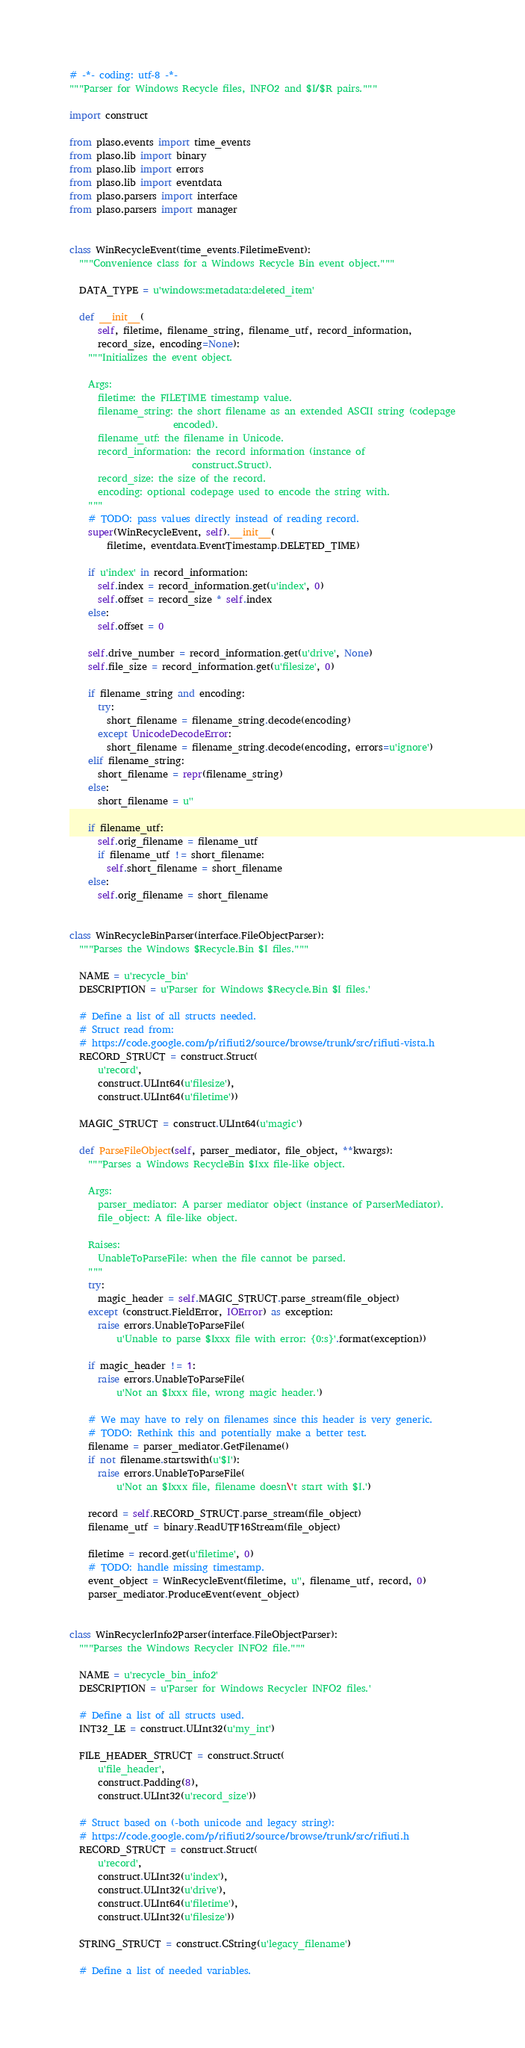<code> <loc_0><loc_0><loc_500><loc_500><_Python_># -*- coding: utf-8 -*-
"""Parser for Windows Recycle files, INFO2 and $I/$R pairs."""

import construct

from plaso.events import time_events
from plaso.lib import binary
from plaso.lib import errors
from plaso.lib import eventdata
from plaso.parsers import interface
from plaso.parsers import manager


class WinRecycleEvent(time_events.FiletimeEvent):
  """Convenience class for a Windows Recycle Bin event object."""

  DATA_TYPE = u'windows:metadata:deleted_item'

  def __init__(
      self, filetime, filename_string, filename_utf, record_information,
      record_size, encoding=None):
    """Initializes the event object.

    Args:
      filetime: the FILETIME timestamp value.
      filename_string: the short filename as an extended ASCII string (codepage
                      encoded).
      filename_utf: the filename in Unicode.
      record_information: the record information (instance of
                          construct.Struct).
      record_size: the size of the record.
      encoding: optional codepage used to encode the string with.
    """
    # TODO: pass values directly instead of reading record.
    super(WinRecycleEvent, self).__init__(
        filetime, eventdata.EventTimestamp.DELETED_TIME)

    if u'index' in record_information:
      self.index = record_information.get(u'index', 0)
      self.offset = record_size * self.index
    else:
      self.offset = 0

    self.drive_number = record_information.get(u'drive', None)
    self.file_size = record_information.get(u'filesize', 0)

    if filename_string and encoding:
      try:
        short_filename = filename_string.decode(encoding)
      except UnicodeDecodeError:
        short_filename = filename_string.decode(encoding, errors=u'ignore')
    elif filename_string:
      short_filename = repr(filename_string)
    else:
      short_filename = u''

    if filename_utf:
      self.orig_filename = filename_utf
      if filename_utf != short_filename:
        self.short_filename = short_filename
    else:
      self.orig_filename = short_filename


class WinRecycleBinParser(interface.FileObjectParser):
  """Parses the Windows $Recycle.Bin $I files."""

  NAME = u'recycle_bin'
  DESCRIPTION = u'Parser for Windows $Recycle.Bin $I files.'

  # Define a list of all structs needed.
  # Struct read from:
  # https://code.google.com/p/rifiuti2/source/browse/trunk/src/rifiuti-vista.h
  RECORD_STRUCT = construct.Struct(
      u'record',
      construct.ULInt64(u'filesize'),
      construct.ULInt64(u'filetime'))

  MAGIC_STRUCT = construct.ULInt64(u'magic')

  def ParseFileObject(self, parser_mediator, file_object, **kwargs):
    """Parses a Windows RecycleBin $Ixx file-like object.

    Args:
      parser_mediator: A parser mediator object (instance of ParserMediator).
      file_object: A file-like object.

    Raises:
      UnableToParseFile: when the file cannot be parsed.
    """
    try:
      magic_header = self.MAGIC_STRUCT.parse_stream(file_object)
    except (construct.FieldError, IOError) as exception:
      raise errors.UnableToParseFile(
          u'Unable to parse $Ixxx file with error: {0:s}'.format(exception))

    if magic_header != 1:
      raise errors.UnableToParseFile(
          u'Not an $Ixxx file, wrong magic header.')

    # We may have to rely on filenames since this header is very generic.
    # TODO: Rethink this and potentially make a better test.
    filename = parser_mediator.GetFilename()
    if not filename.startswith(u'$I'):
      raise errors.UnableToParseFile(
          u'Not an $Ixxx file, filename doesn\'t start with $I.')

    record = self.RECORD_STRUCT.parse_stream(file_object)
    filename_utf = binary.ReadUTF16Stream(file_object)

    filetime = record.get(u'filetime', 0)
    # TODO: handle missing timestamp.
    event_object = WinRecycleEvent(filetime, u'', filename_utf, record, 0)
    parser_mediator.ProduceEvent(event_object)


class WinRecyclerInfo2Parser(interface.FileObjectParser):
  """Parses the Windows Recycler INFO2 file."""

  NAME = u'recycle_bin_info2'
  DESCRIPTION = u'Parser for Windows Recycler INFO2 files.'

  # Define a list of all structs used.
  INT32_LE = construct.ULInt32(u'my_int')

  FILE_HEADER_STRUCT = construct.Struct(
      u'file_header',
      construct.Padding(8),
      construct.ULInt32(u'record_size'))

  # Struct based on (-both unicode and legacy string):
  # https://code.google.com/p/rifiuti2/source/browse/trunk/src/rifiuti.h
  RECORD_STRUCT = construct.Struct(
      u'record',
      construct.ULInt32(u'index'),
      construct.ULInt32(u'drive'),
      construct.ULInt64(u'filetime'),
      construct.ULInt32(u'filesize'))

  STRING_STRUCT = construct.CString(u'legacy_filename')

  # Define a list of needed variables.</code> 